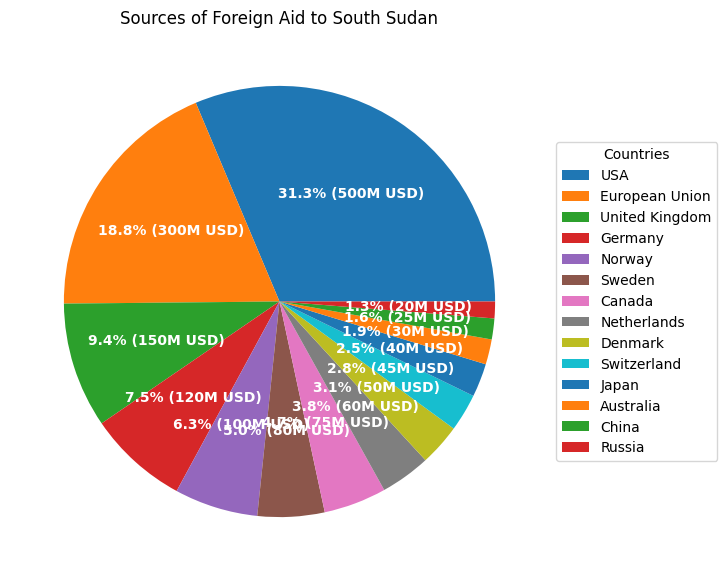Which country contributes the highest amount of foreign aid to South Sudan? The largest segment of the pie chart represents the USA, indicating that it contributes the highest amount of foreign aid to South Sudan.
Answer: USA What is the combined total of foreign aid from European Union and United Kingdom? The pie chart shows that the European Union contributes 300 million USD, and the United Kingdom contributes 150 million USD. Adding these amounts gives 300 + 150 = 450 million USD.
Answer: 450 million USD Which country contributes less, Norway or Canada? According to the pie chart, Norway contributes 100 million USD and Canada contributes 75 million USD. Therefore, Canada contributes less than Norway.
Answer: Canada How does the contribution from Germany compare to that from the United Kingdom? The pie chart shows Germany contributes 120 million USD while the United Kingdom contributes 150 million USD. Comparing these amounts, Germany contributes less than the United Kingdom.
Answer: Germany contributes less than the United Kingdom What is the total amount of foreign aid contributed by Japan, Australia, and China combined? The pie chart shows that Japan contributes 40 million USD, Australia contributes 30 million USD, and China contributes 25 million USD. Adding these amounts gives 40 + 30 + 25 = 95 million USD.
Answer: 95 million USD By how much does the USA's contribution exceed that of the European Union? The pie chart shows the USA contributes 500 million USD and the European Union contributes 300 million USD. Subtracting these values gives 500 - 300 = 200 million USD.
Answer: 200 million USD What is the total percentage of foreign aid provided by Denmark and Switzerland combined? From the pie chart, Denmark contributes 50 million USD and Switzerland contributes 45 million USD. The total is 50 + 45 = 95 million USD. To find the percentage, calculate 95 divided by the total foreign aid and then multiply by 100. (Total foreign aid is 1695 million USD; 95/1695 * 100 ≈ 5.6%).
Answer: 5.6% Which two countries collectively contribute 250 million USD in foreign aid to South Sudan? From the pie chart, the United Kingdom (150 million USD) and Germany (100 million USD) collectively contribute 150 + 100 = 250 million USD.
Answer: United Kingdom and Germany Is Norway's contribution larger or smaller than Sweden's? The pie chart shows Norway contributes 100 million USD and Sweden contributes 80 million USD. Hence, Norway's contribution is larger than Sweden's.
Answer: Larger What is the visual difference in the size of the pie segments for Canada and Netherlands? The pie chart shows Canada's segment is slightly larger than that of the Netherlands. Canada contributes 75 million USD while the Netherlands contributes 60 million USD, indicating a visual difference corresponding to the 15 million USD difference.
Answer: Canada’s segment is larger 